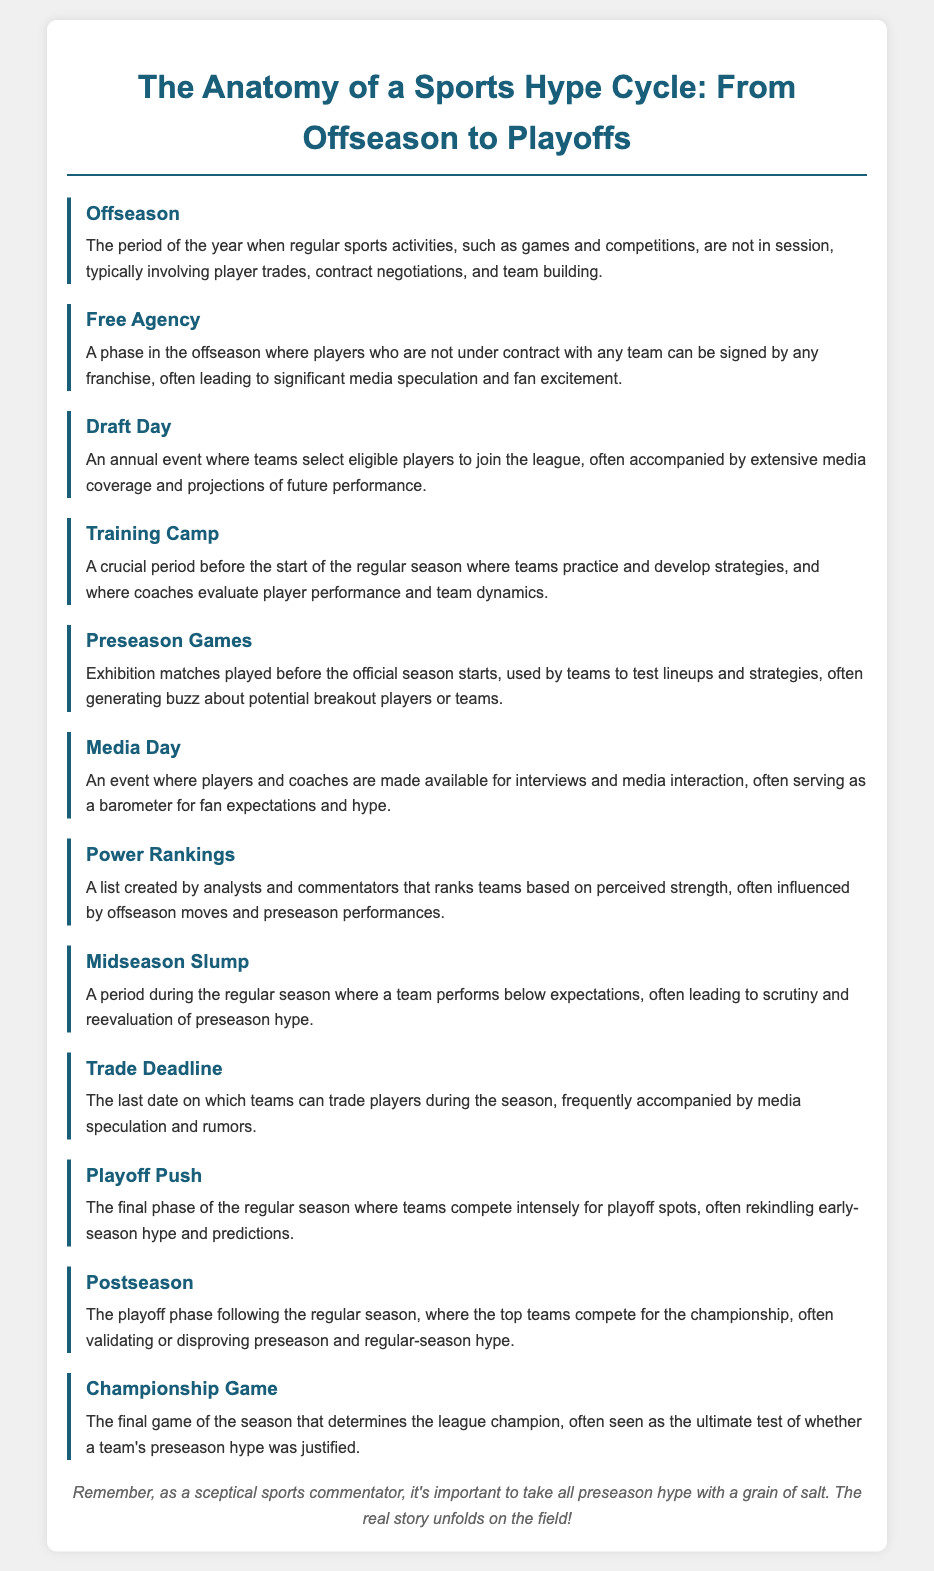What is the definition of Offseason? Offseason is defined as the period of the year when regular sports activities, such as games and competitions, are not in session, typically involving player trades, contract negotiations, and team building.
Answer: The period of the year when regular sports activities are not in session What does Free Agency refer to? Free Agency refers to a phase in the offseason where players who are not under contract with any team can be signed by any franchise, often leading to significant media speculation and fan excitement.
Answer: A phase where players can be signed by any franchise What is evaluated during Training Camp? During Training Camp, coaches evaluate player performance and team dynamics as teams practice and develop strategies before the start of the regular season.
Answer: Player performance and team dynamics What is the significance of Draft Day? Draft Day is significant as it is an annual event where teams select eligible players to join the league, often accompanied by extensive media coverage and projections of future performance.
Answer: Annual event for teams to select eligible players What is usually speculated during the Trade Deadline? During the Trade Deadline, media speculation and rumors regarding player trades often occur, reflecting the intense competition and strategic decisions being made by teams.
Answer: Media speculation and rumors regarding player trades What is a Midseason Slump? A Midseason Slump is described as a period during the regular season where a team performs below expectations, often leading to scrutiny and reevaluation of preseason hype.
Answer: A period of below-expectations performance during the regular season What happens during the Playoff Push? During the Playoff Push, teams compete intensely for playoff spots, often rekindling early-season hype and predictions about their potential success.
Answer: Teams compete for playoff spots What does Postseason refer to? The Postseason refers to the playoff phase following the regular season, where the top teams compete for the championship, often validating or disproving preseason and regular-season hype.
Answer: The playoff phase following the regular season What is a Championship Game? The Championship Game is defined as the final game of the season that determines the league champion, often seen as the ultimate test of whether a team's preseason hype was justified.
Answer: The final game that determines the league champion 